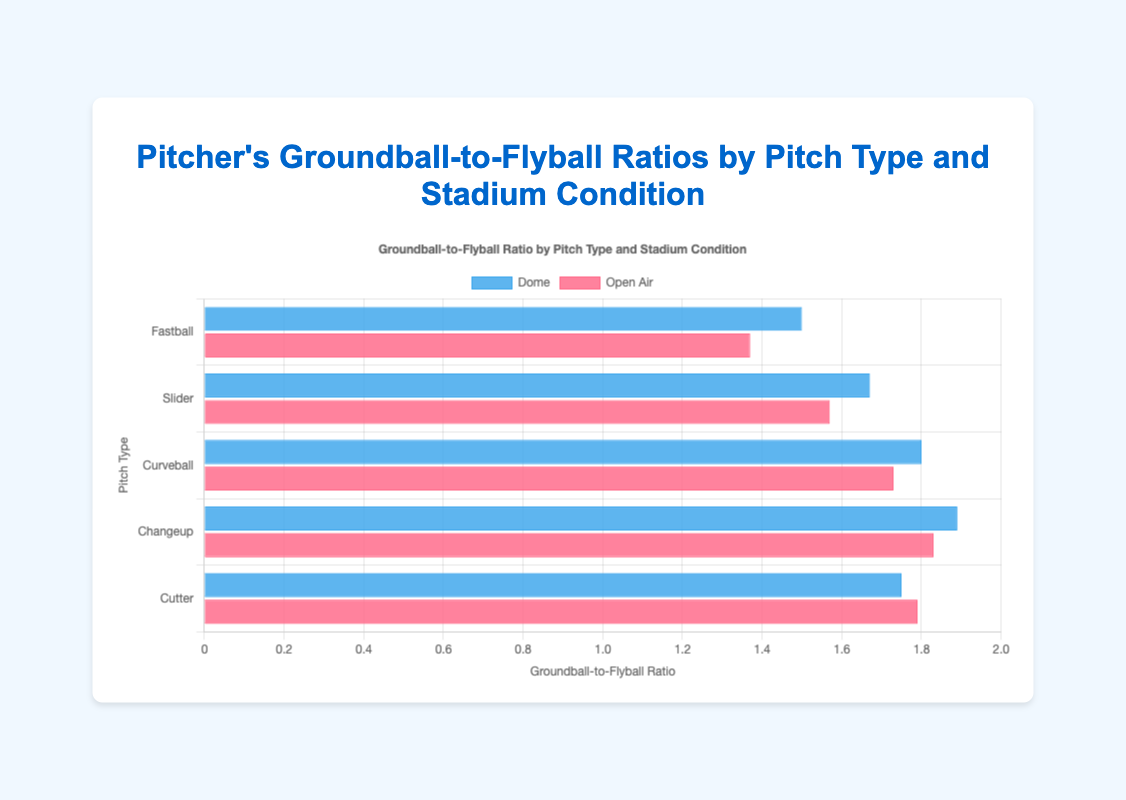Which pitch type has the highest groundball-to-flyball ratio in Dome conditions? To find the pitch type with the highest groundball-to-flyball ratio in Dome conditions, look at the values of the blue bars and identify the highest one. The Changeup has the highest ratio at 1.89.
Answer: Changeup Which pitch type has a higher groundball-to-flyball ratio in Open Air conditions, Fastball or Slider? Compare the red bars representing Fastball and Slider in Open Air conditions. The Fastball ratio is 1.37, and the Slider ratio is 1.57. The Slider has a higher ratio.
Answer: Slider What is the average groundball-to-flyball ratio for all pitch types in Dome conditions? Calculate the average by summing the ratios for Dome conditions and dividing by the number of pitch types: (1.50 + 1.67 + 1.80 + 1.89 + 1.75) / 5 = 1.72.
Answer: 1.72 Is there any pitch type where the groundball-to-flyball ratio is equal in both Dome and Open Air conditions? Check the blue and red bars for each pitch type to see if any have the same height. There is no pitch type where the ratios are equal in both conditions.
Answer: No Which pitching condition, Dome or Open Air, yields generally higher groundball-to-flyball ratios for Curveballs? Compare the bars for Curveballs in both conditions. Dome has a ratio of 1.80, and Open Air has 1.73. Dome yields a higher ratio.
Answer: Dome What is the difference in groundball-to-flyball ratios for Fastballs between Dome and Open Air conditions? Subtract the Open Air ratio from the Dome ratio for Fastballs: 1.50 - 1.37 = 0.13.
Answer: 0.13 Which pitch type shows the smallest difference in groundball-to-flyball ratio between Dome and Open Air conditions? Calculate the difference in ratios for all pitch types and find the smallest one. For Fastball: 0.13, Slider: 0.10, Curveball: 0.07, Changeup: 0.06, Cutter: -0.04. Changeup shows the smallest difference.
Answer: Changeup How many pitch types have a higher groundball-to-flyball ratio in Dome conditions compared to Open Air? Count the pitch types where the blue bar is taller than the red bar. There are 2: Fastball and Curveball.
Answer: 2 What's the combined groundball-to-flyball ratio for all pitch types in Open Air conditions? Sum the ratios for Open Air conditions: 1.37 + 1.57 + 1.73 + 1.83 + 1.79 = 8.29.
Answer: 8.29 